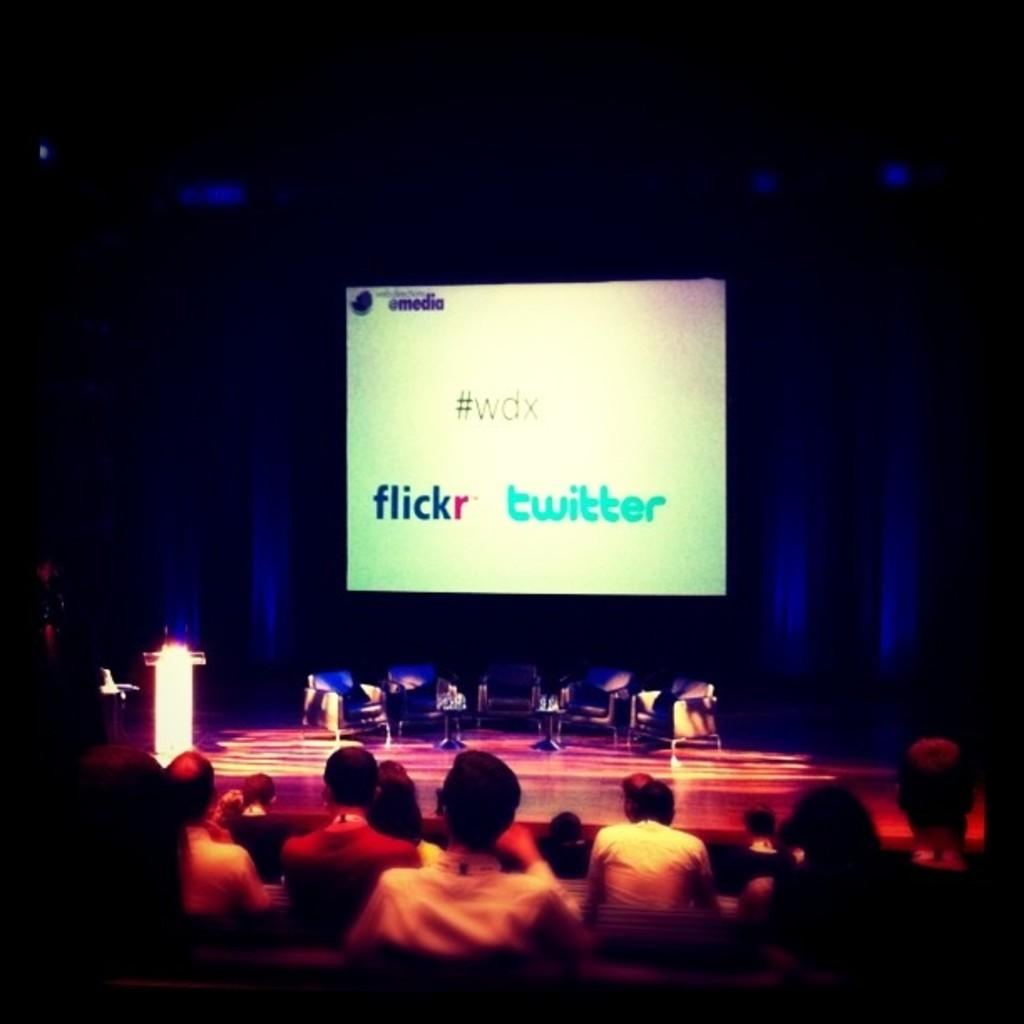What type of furniture is on the stage in the image? There are chairs on the stage in the image. What is located at the front of the stage? There is a podium on the stage. What can be seen behind the stage? There is a screen behind the stage. Where are the people in the image located? People are sitting in the bottom of the image. What time of day does the image depict, and how can you tell? The time of day is not mentioned or depicted in the image, so it cannot be determined. Can you describe the burst of energy coming from the podium? There is no burst of energy depicted in the image; it shows a podium, chairs, a screen, and people sitting. 